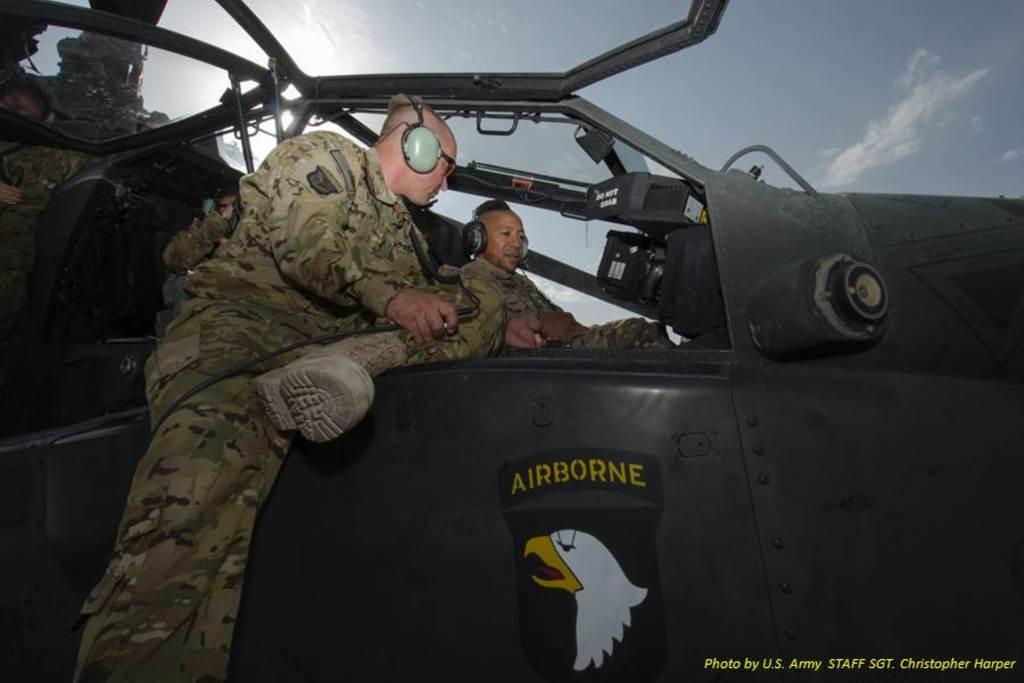What division of the military is this plane from?
Provide a succinct answer. Airborne. 